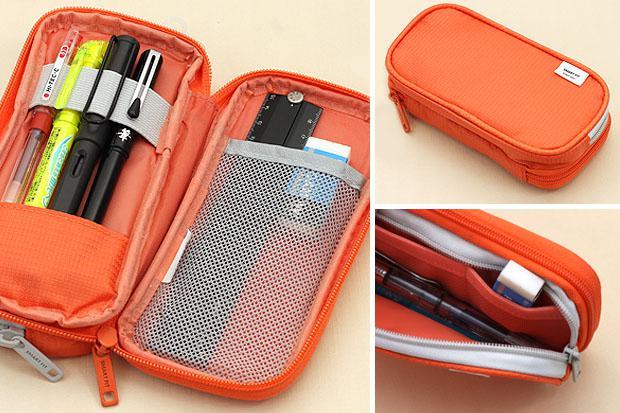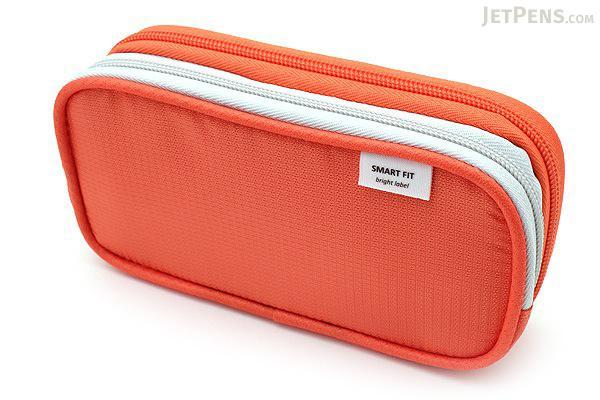The first image is the image on the left, the second image is the image on the right. Evaluate the accuracy of this statement regarding the images: "There is an image of a single closed case and an image showing both the closed and open case.". Is it true? Answer yes or no. Yes. 